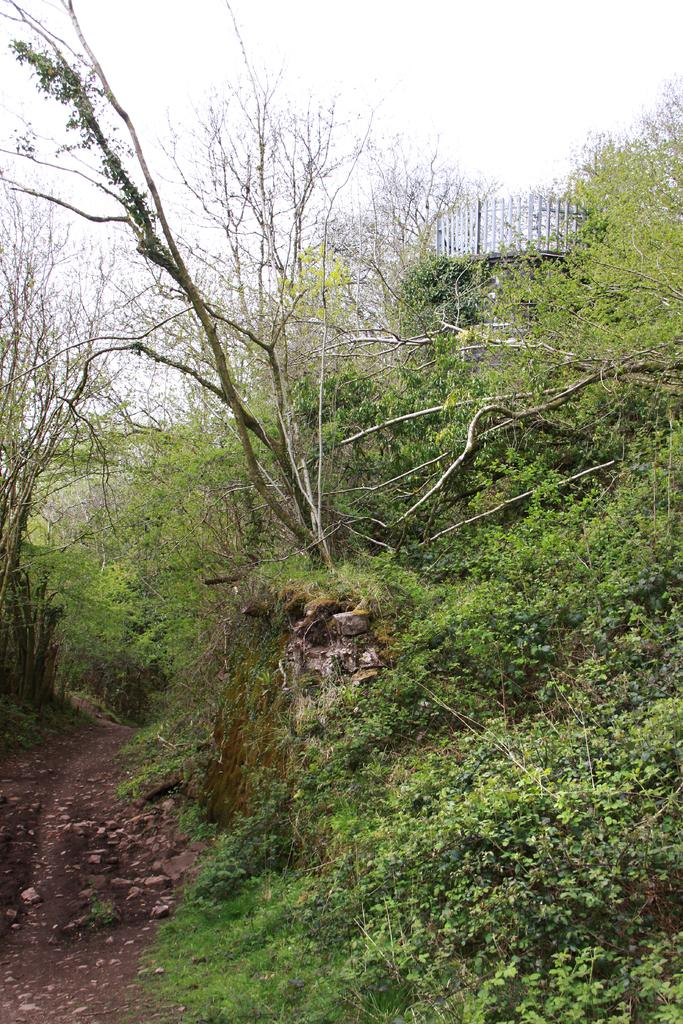What type of vegetation is present in the image? There are many trees and plants in the image. What part of the natural environment is visible at the bottom of the image? The ground is visible at the bottom of the image. What part of the natural environment is visible at the top of the image? The sky is visible at the top of the image. What type of location does the image appear to depict? The image appears to depict a forest. Can you tell me how the queen is involved in the image? There is no queen present in the image; it depicts a forest with trees, plants, ground, and sky. What is the hope for the plants in the image? The image does not convey any specific hopes or intentions for the plants; it simply shows them as part of the natural environment. 